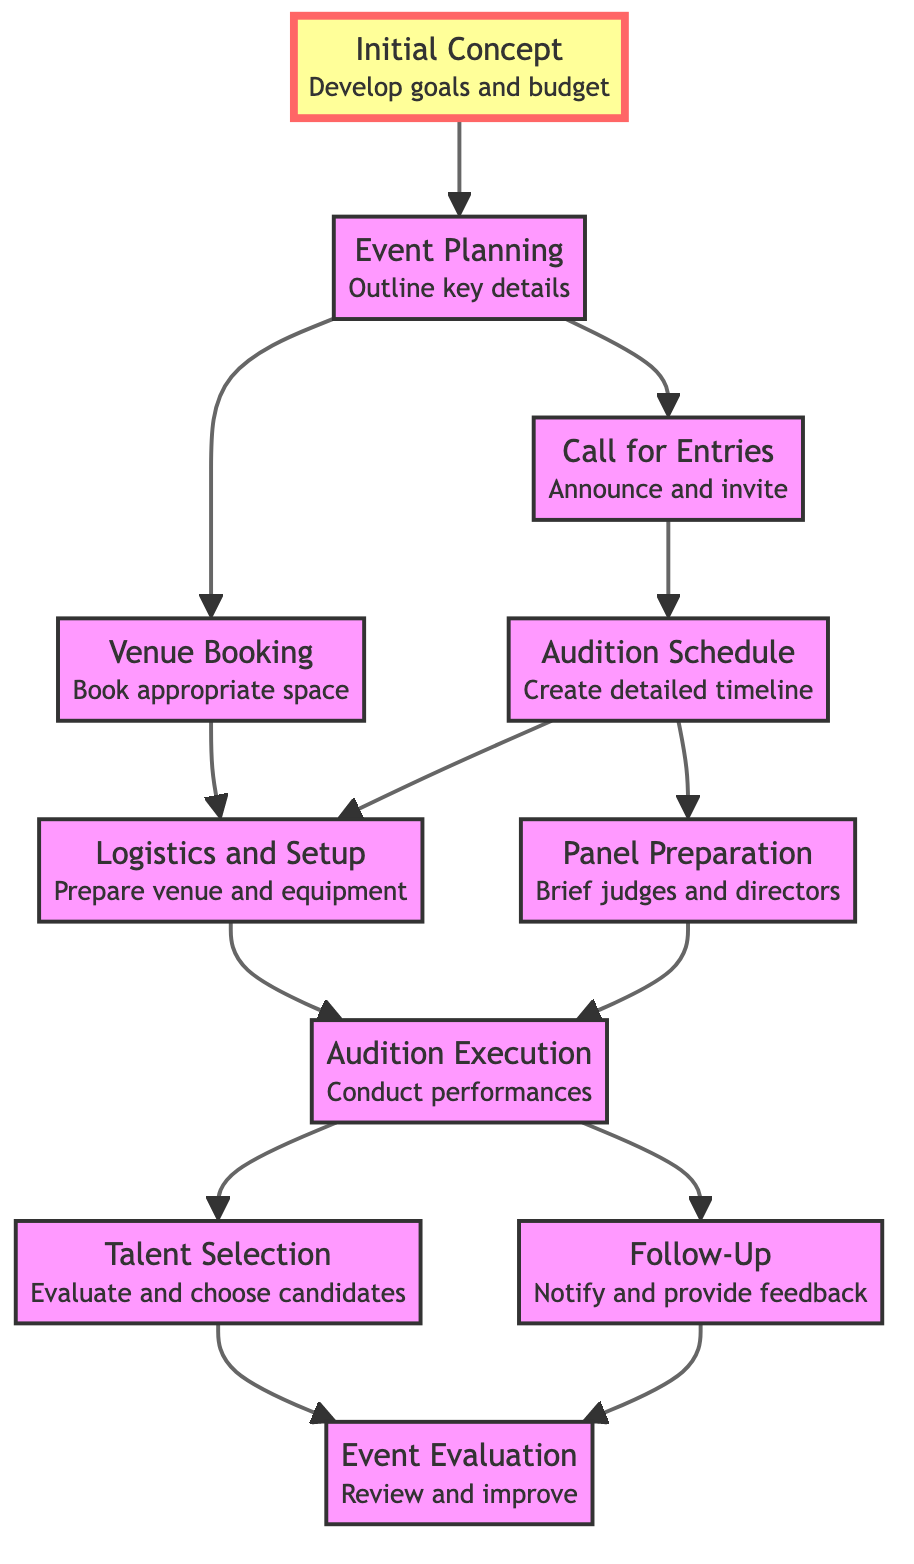What is the first step in the process? The first step is represented by the node 'Initial Concept', which is the starting point of the flow and has no dependencies.
Answer: Initial Concept How many total nodes are in this diagram? By counting all the distinct steps from 'Initial Concept' to 'Event Evaluation', we find there are 10 nodes.
Answer: 10 What comes immediately after 'Logistics and Setup'? The flow shows that 'Logistics and Setup' leads directly to 'Audition Execution', as indicated by the arrow connecting these two nodes.
Answer: Audition Execution What is the final step in the process? The last node in the flow is 'Event Evaluation', which happens after both 'Talent Selection' and 'Follow-Up' are completed.
Answer: Event Evaluation What documents should be prepared before 'Audition Execution'? The 'Panel Preparation' node indicates that judges and casting directors need to be prepared with the necessary documents.
Answer: Judges and casting directors Which step relies on both 'Audition Schedule' and 'Venue Booking'? Looking at the diagram, 'Logistics and Setup' depends on both 'Audition Schedule' and 'Venue Booking', as shown by the arrows pointing to it.
Answer: Logistics and Setup How does 'Talent Selection' relate to 'Audition Execution'? 'Talent Selection' happens after 'Audition Execution', indicating that performances must be conducted before evaluation can take place.
Answer: Sequential process What two steps lead to 'Follow-Up'? Both 'Audition Execution' directly influence 'Follow-Up', meaning after the audition has taken place, the follow-up process begins.
Answer: Audition Execution Which node indicates the need for an announcement to invite talent? The 'Call for Entries' node is where the announcement is made to invite talent, directly linked from the 'Event Planning'.
Answer: Call for Entries 